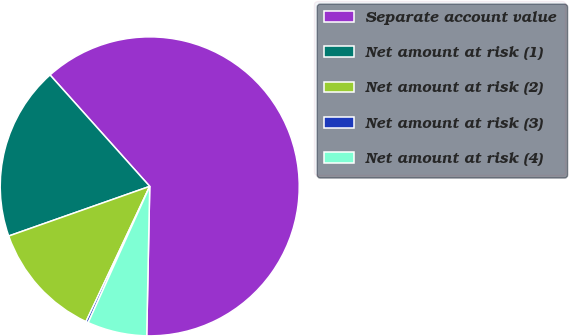<chart> <loc_0><loc_0><loc_500><loc_500><pie_chart><fcel>Separate account value<fcel>Net amount at risk (1)<fcel>Net amount at risk (2)<fcel>Net amount at risk (3)<fcel>Net amount at risk (4)<nl><fcel>61.94%<fcel>18.77%<fcel>12.6%<fcel>0.26%<fcel>6.43%<nl></chart> 